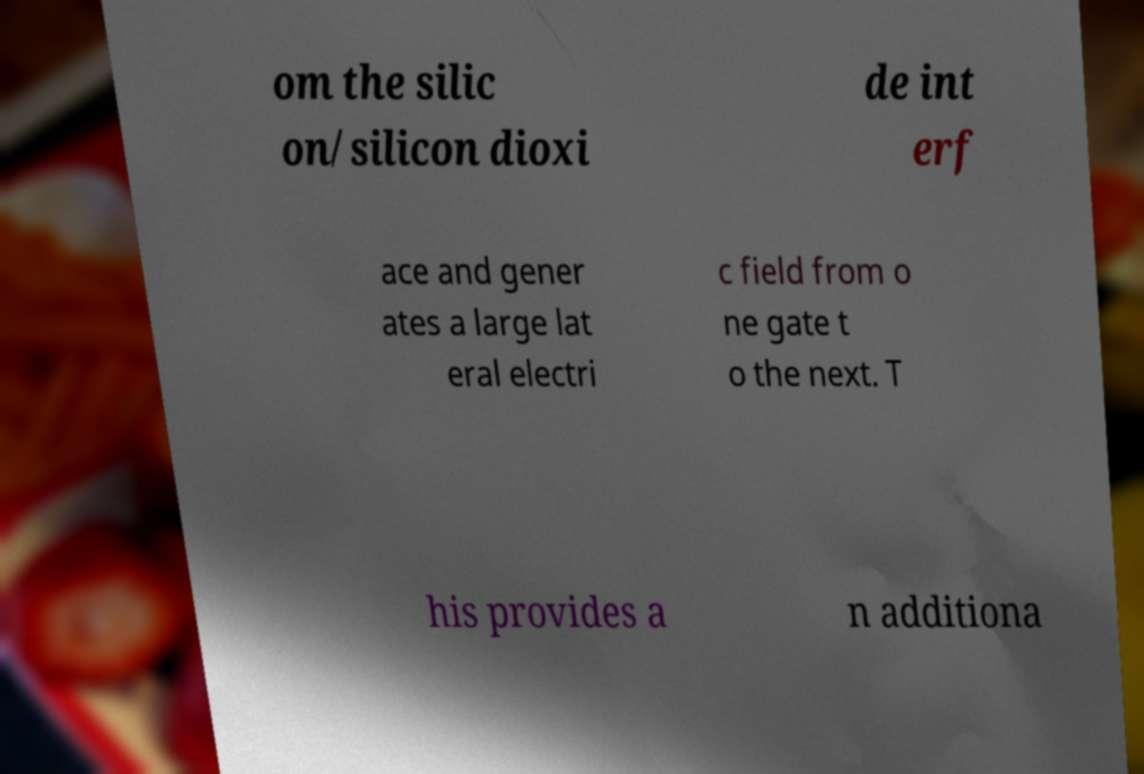For documentation purposes, I need the text within this image transcribed. Could you provide that? om the silic on/silicon dioxi de int erf ace and gener ates a large lat eral electri c field from o ne gate t o the next. T his provides a n additiona 